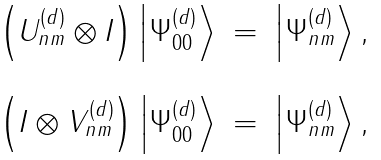Convert formula to latex. <formula><loc_0><loc_0><loc_500><loc_500>\begin{array} { l c r } \left ( U _ { n m } ^ { ( d ) } \otimes I \right ) \left | { \Psi } _ { 0 0 } ^ { ( d ) } \right \rangle & = & \left | { \Psi } _ { n m } ^ { ( d ) } \right \rangle , \\ \\ \left ( I \otimes V _ { n m } ^ { ( d ) } \right ) \left | { \Psi } _ { 0 0 } ^ { ( d ) } \right \rangle & = & \left | { \Psi } _ { n m } ^ { ( d ) } \right \rangle , \end{array}</formula> 